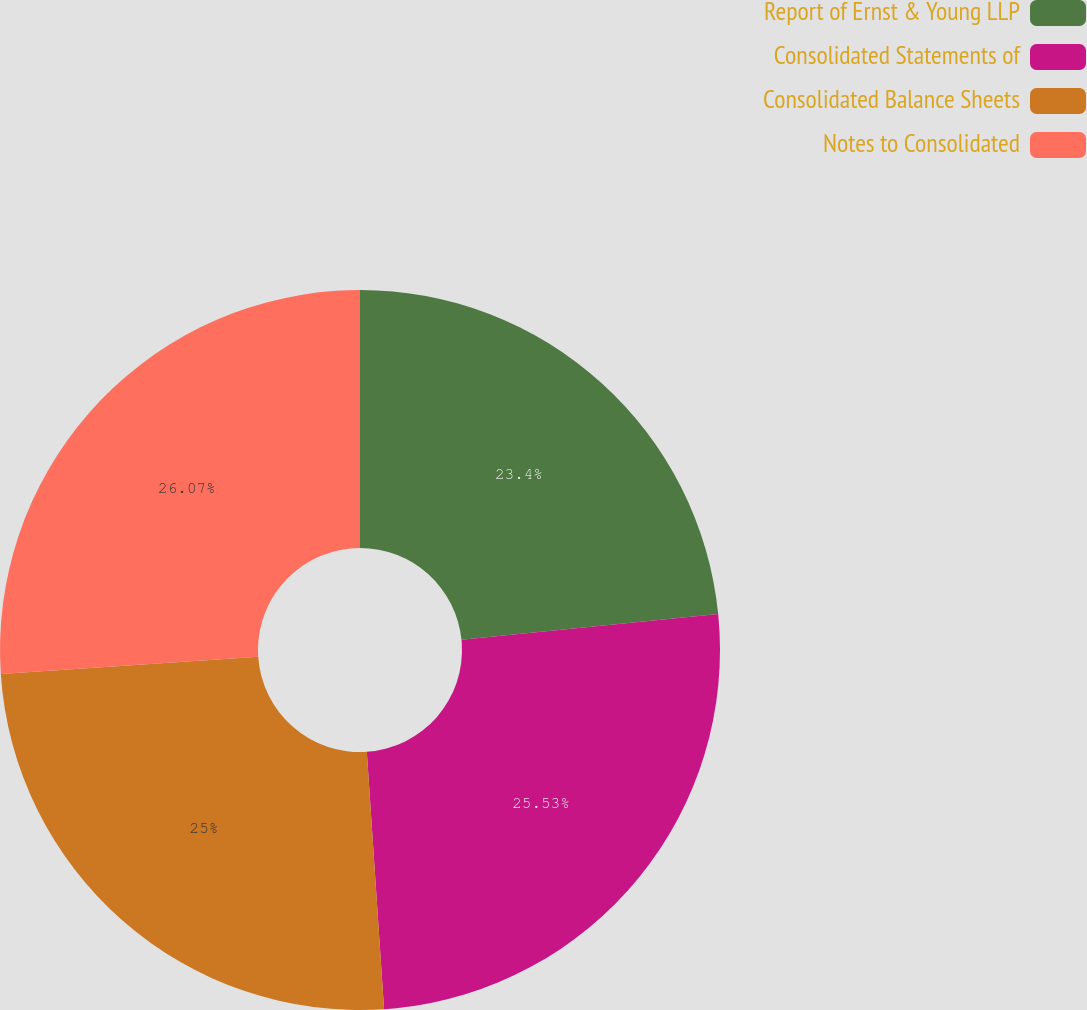Convert chart to OTSL. <chart><loc_0><loc_0><loc_500><loc_500><pie_chart><fcel>Report of Ernst & Young LLP<fcel>Consolidated Statements of<fcel>Consolidated Balance Sheets<fcel>Notes to Consolidated<nl><fcel>23.4%<fcel>25.53%<fcel>25.0%<fcel>26.06%<nl></chart> 